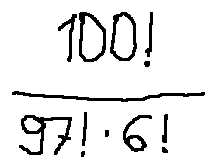Convert formula to latex. <formula><loc_0><loc_0><loc_500><loc_500>\frac { 1 0 0 ! } { 9 7 ! \cdot 6 ! }</formula> 